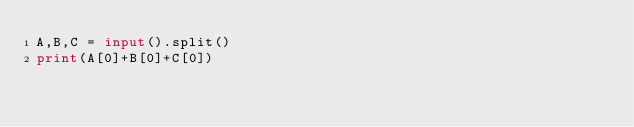<code> <loc_0><loc_0><loc_500><loc_500><_Python_>A,B,C = input().split()
print(A[0]+B[0]+C[0])</code> 